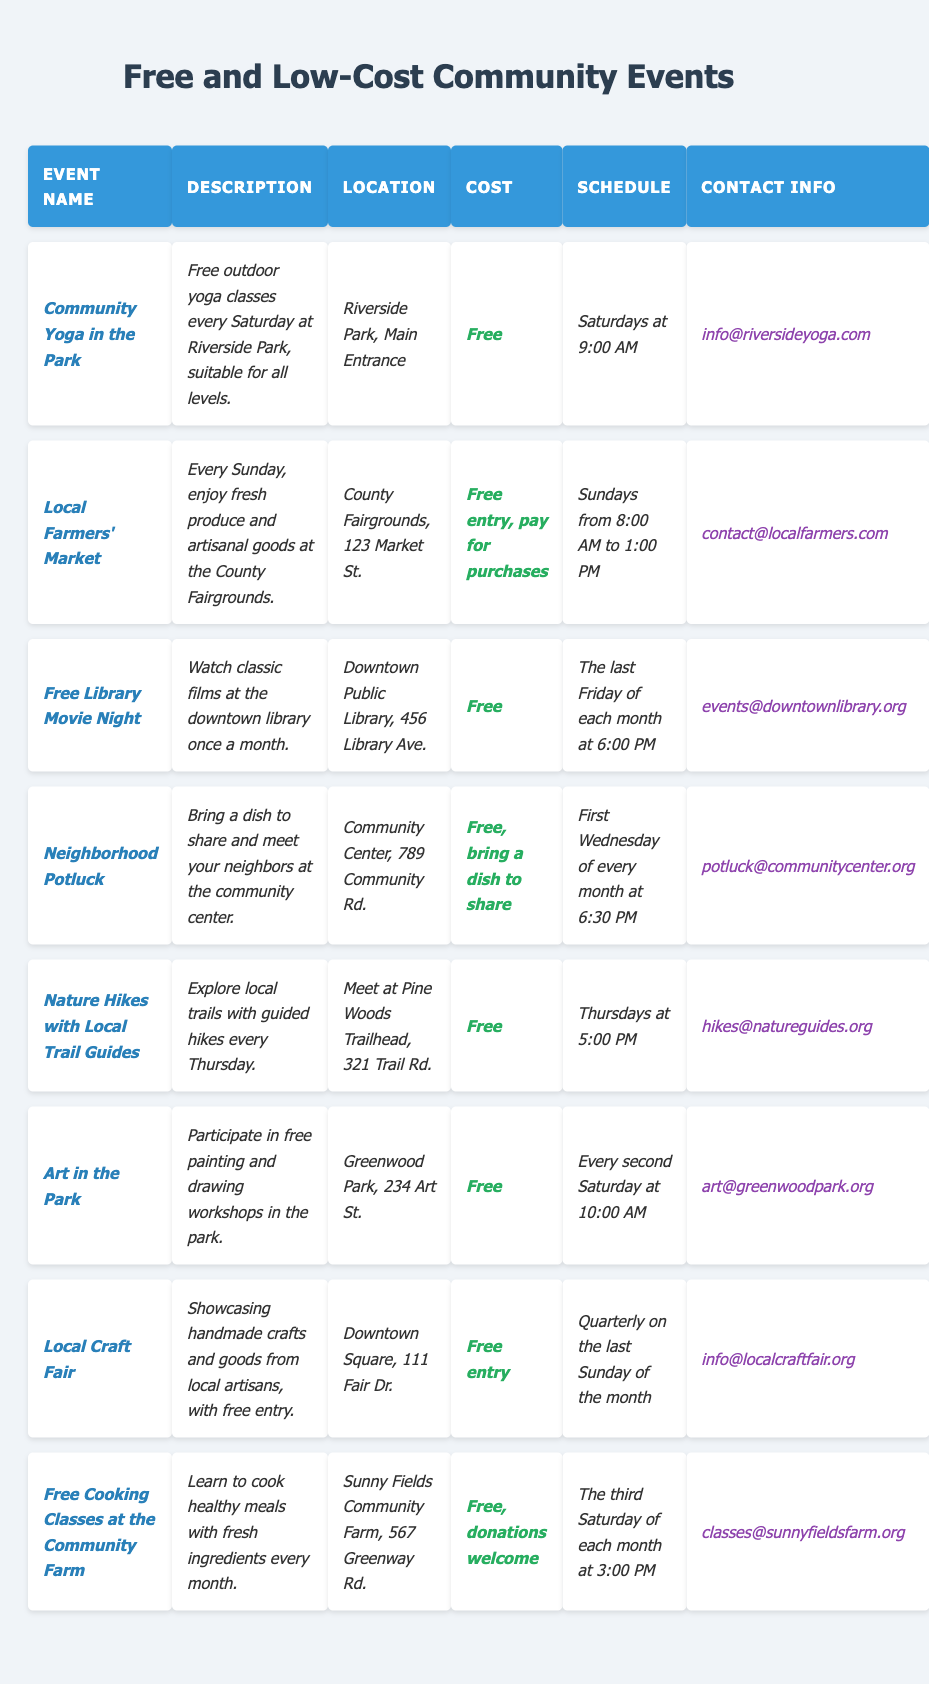What is the cost of attending the *Nature Hikes with Local Trail Guides* event? The table shows that the cost for this event is listed under the "Cost" column, which states: "*Free*".
Answer: Free What day of the week does the *Local Farmers' Market* take place? From the "Schedule" column of the table, it specifies that the *Local Farmers' Market* occurs on "Sundays from 8:00 AM to 1:00 PM".
Answer: Sunday Which event requires participants to bring a dish to share? The table indicates that the *Neighborhood Potluck* event states, "*Free, bring a dish to share*", making it clear that this is the requirement for this event.
Answer: Neighborhood Potluck How often does the *Free Library Movie Night* occur? Looking at the "Schedule" column, the *Free Library Movie Night* takes place "The last Friday of each month", indicating that it happens once every month.
Answer: Monthly Is there a contact email provided for the *Art in the Park* event? In the "Contact Info" column for *Art in the Park*, it shows the email as "*art@greenwoodpark.org*", confirming that an email is provided.
Answer: Yes How many events happen on Saturdays? By checking the schedule, we find that *Community Yoga in the Park* and *Art in the Park* are both on Saturdays. Thus, there are two events scheduled for Saturdays.
Answer: 2 Which event takes place at the *Community Center*? The table shows that the event held at the Community Center is *Neighborhood Potluck*, as it specifies "*Community Center, 789 Community Rd.*" in the location column.
Answer: Neighborhood Potluck Which event offers cooking classes and how often? The table lists *Free Cooking Classes at the Community Farm* under the event name, and it states in the schedule that it occurs "The third Saturday of each month".
Answer: Free Cooking Classes at the Community Farm, Monthly List the events that are completely free to attend. Referring to the "Cost" column, the events *Community Yoga in the Park*, *Free Library Movie Night*, *Nature Hikes with Local Trail Guides*, *Art in the Park*, and *Local Craft Fair* are all listed as "*Free*".
Answer: Community Yoga in the Park, Free Library Movie Night, Nature Hikes with Local Trail Guides, Art in the Park, Local Craft Fair What is the timing for the *Nature Hikes with Local Trail Guides*? The schedule specifies that the *Nature Hikes with Local Trail Guides* occur on "Thursdays at 5:00 PM".
Answer: Thursdays at 5:00 PM 